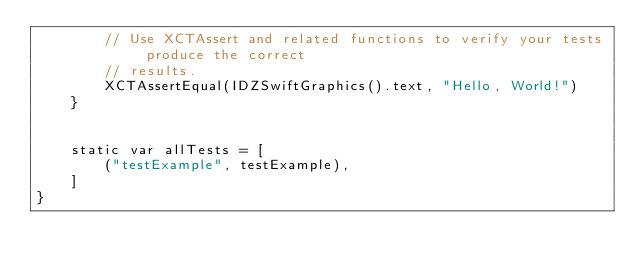<code> <loc_0><loc_0><loc_500><loc_500><_Swift_>        // Use XCTAssert and related functions to verify your tests produce the correct
        // results.
        XCTAssertEqual(IDZSwiftGraphics().text, "Hello, World!")
    }


    static var allTests = [
        ("testExample", testExample),
    ]
}
</code> 